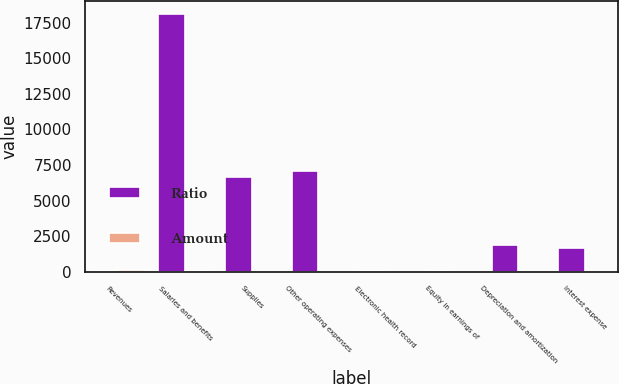Convert chart to OTSL. <chart><loc_0><loc_0><loc_500><loc_500><stacked_bar_chart><ecel><fcel>Revenues<fcel>Salaries and benefits<fcel>Supplies<fcel>Other operating expenses<fcel>Electronic health record<fcel>Equity in earnings of<fcel>Depreciation and amortization<fcel>Interest expense<nl><fcel>Ratio<fcel>46<fcel>18115<fcel>6638<fcel>7103<fcel>47<fcel>46<fcel>1904<fcel>1665<nl><fcel>Amount<fcel>100<fcel>45.7<fcel>16.7<fcel>17.9<fcel>0.1<fcel>0.1<fcel>4.8<fcel>4.2<nl></chart> 